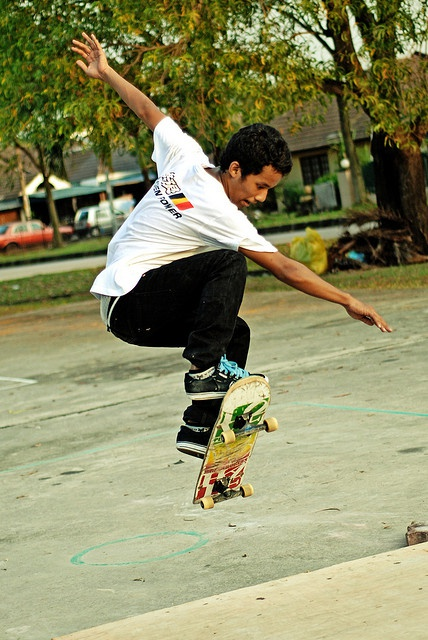Describe the objects in this image and their specific colors. I can see people in darkgreen, black, white, brown, and tan tones, skateboard in darkgreen, khaki, tan, and black tones, car in darkgreen, salmon, maroon, black, and red tones, and car in darkgreen, black, gray, beige, and darkgray tones in this image. 